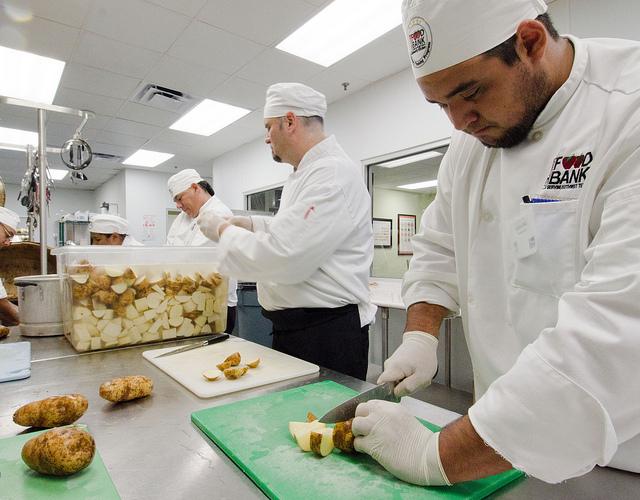What is this man cooking?
Keep it brief. Potatoes. Is this a home kitchen or a commercial kitchen?
Short answer required. Commercial. Where do these chefs work?
Answer briefly. Food bank. What does the chef chopping?
Write a very short answer. Potatoes. 